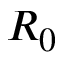Convert formula to latex. <formula><loc_0><loc_0><loc_500><loc_500>R _ { 0 }</formula> 